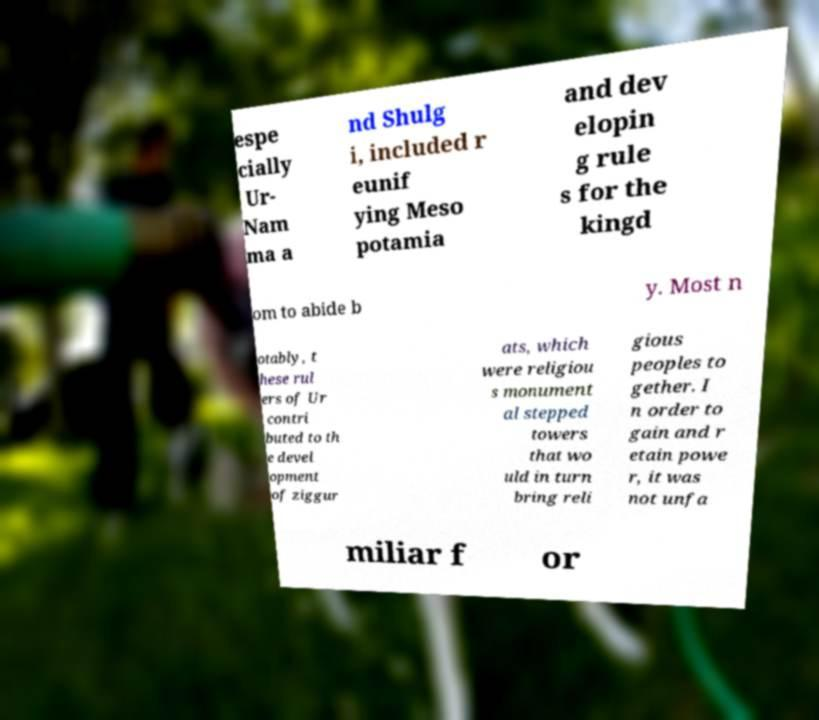There's text embedded in this image that I need extracted. Can you transcribe it verbatim? espe cially Ur- Nam ma a nd Shulg i, included r eunif ying Meso potamia and dev elopin g rule s for the kingd om to abide b y. Most n otably, t hese rul ers of Ur contri buted to th e devel opment of ziggur ats, which were religiou s monument al stepped towers that wo uld in turn bring reli gious peoples to gether. I n order to gain and r etain powe r, it was not unfa miliar f or 